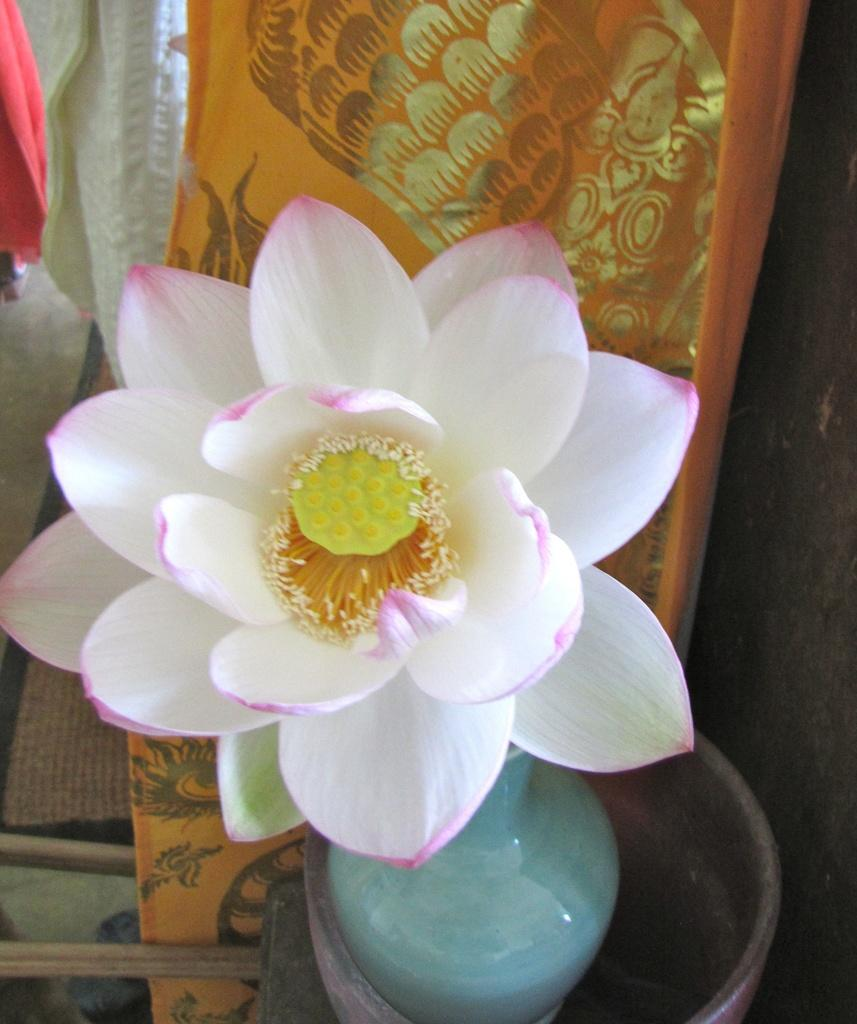What is the main subject in the center of the image? There is a flower in the center of the image. What is the flower placed in? There is a flower vase in an object at the bottom of the image. What can be seen in the background of the image? Clothes are visible in the background of the image. What type of legal advice can be obtained from the flower in the image? The flower in the image is not a lawyer and cannot provide legal advice. 